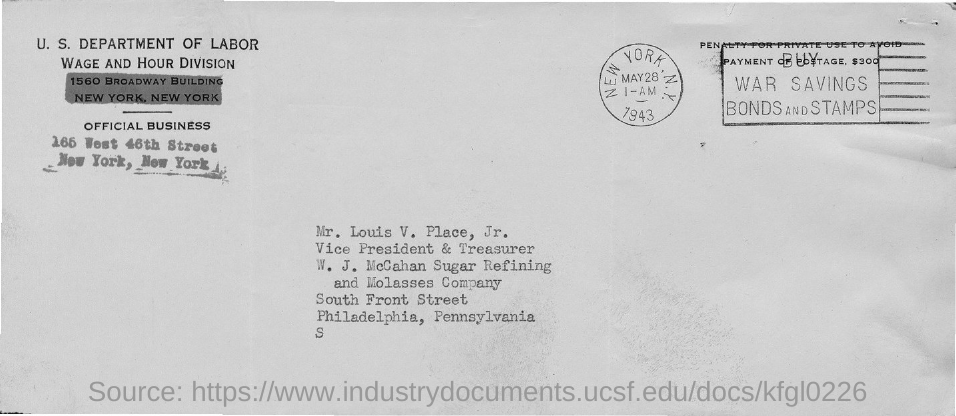Identify some key points in this picture. The name of the person addressed in the address is Mr. Louis V. Place Jr. 